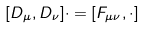<formula> <loc_0><loc_0><loc_500><loc_500>[ D _ { \mu } , D _ { \nu } ] \cdot = [ F _ { \mu \nu } , \cdot ]</formula> 